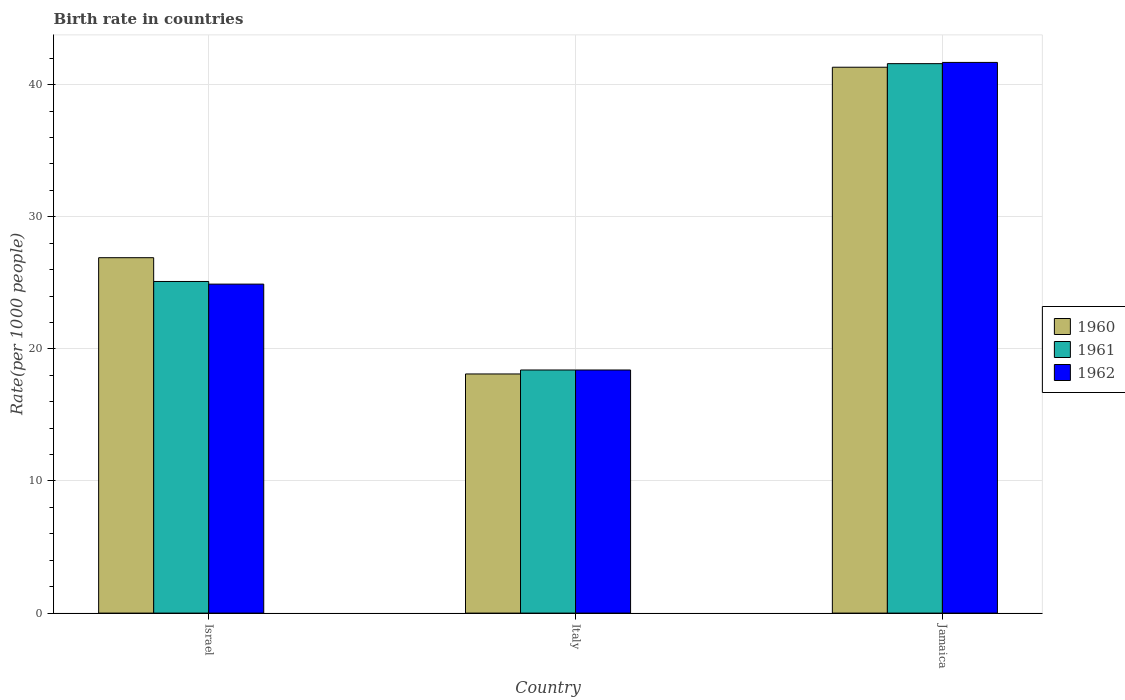How many different coloured bars are there?
Offer a very short reply. 3. How many groups of bars are there?
Ensure brevity in your answer.  3. Are the number of bars per tick equal to the number of legend labels?
Ensure brevity in your answer.  Yes. Are the number of bars on each tick of the X-axis equal?
Make the answer very short. Yes. How many bars are there on the 1st tick from the right?
Provide a short and direct response. 3. What is the label of the 3rd group of bars from the left?
Ensure brevity in your answer.  Jamaica. Across all countries, what is the maximum birth rate in 1960?
Ensure brevity in your answer.  41.32. Across all countries, what is the minimum birth rate in 1960?
Your response must be concise. 18.1. In which country was the birth rate in 1962 maximum?
Offer a terse response. Jamaica. What is the total birth rate in 1960 in the graph?
Your response must be concise. 86.32. What is the difference between the birth rate in 1961 in Italy and that in Jamaica?
Offer a terse response. -23.19. What is the difference between the birth rate in 1961 in Israel and the birth rate in 1962 in Italy?
Provide a short and direct response. 6.7. What is the average birth rate in 1962 per country?
Make the answer very short. 28.33. What is the difference between the birth rate of/in 1961 and birth rate of/in 1960 in Jamaica?
Keep it short and to the point. 0.27. What is the ratio of the birth rate in 1962 in Israel to that in Jamaica?
Make the answer very short. 0.6. What is the difference between the highest and the second highest birth rate in 1960?
Give a very brief answer. 14.42. What is the difference between the highest and the lowest birth rate in 1960?
Provide a succinct answer. 23.22. In how many countries, is the birth rate in 1961 greater than the average birth rate in 1961 taken over all countries?
Give a very brief answer. 1. Is it the case that in every country, the sum of the birth rate in 1960 and birth rate in 1962 is greater than the birth rate in 1961?
Your response must be concise. Yes. How many bars are there?
Your answer should be compact. 9. What is the difference between two consecutive major ticks on the Y-axis?
Your answer should be very brief. 10. Are the values on the major ticks of Y-axis written in scientific E-notation?
Keep it short and to the point. No. Does the graph contain any zero values?
Keep it short and to the point. No. Does the graph contain grids?
Your answer should be compact. Yes. What is the title of the graph?
Keep it short and to the point. Birth rate in countries. Does "2003" appear as one of the legend labels in the graph?
Offer a very short reply. No. What is the label or title of the X-axis?
Offer a terse response. Country. What is the label or title of the Y-axis?
Make the answer very short. Rate(per 1000 people). What is the Rate(per 1000 people) in 1960 in Israel?
Your response must be concise. 26.9. What is the Rate(per 1000 people) in 1961 in Israel?
Your response must be concise. 25.1. What is the Rate(per 1000 people) in 1962 in Israel?
Your response must be concise. 24.9. What is the Rate(per 1000 people) in 1960 in Italy?
Provide a short and direct response. 18.1. What is the Rate(per 1000 people) in 1961 in Italy?
Your response must be concise. 18.4. What is the Rate(per 1000 people) in 1962 in Italy?
Make the answer very short. 18.4. What is the Rate(per 1000 people) in 1960 in Jamaica?
Provide a short and direct response. 41.32. What is the Rate(per 1000 people) of 1961 in Jamaica?
Provide a short and direct response. 41.59. What is the Rate(per 1000 people) in 1962 in Jamaica?
Provide a short and direct response. 41.68. Across all countries, what is the maximum Rate(per 1000 people) of 1960?
Your answer should be compact. 41.32. Across all countries, what is the maximum Rate(per 1000 people) of 1961?
Your answer should be compact. 41.59. Across all countries, what is the maximum Rate(per 1000 people) of 1962?
Ensure brevity in your answer.  41.68. What is the total Rate(per 1000 people) in 1960 in the graph?
Provide a short and direct response. 86.32. What is the total Rate(per 1000 people) of 1961 in the graph?
Provide a succinct answer. 85.09. What is the total Rate(per 1000 people) of 1962 in the graph?
Offer a very short reply. 84.98. What is the difference between the Rate(per 1000 people) in 1960 in Israel and that in Italy?
Make the answer very short. 8.8. What is the difference between the Rate(per 1000 people) of 1961 in Israel and that in Italy?
Your answer should be very brief. 6.7. What is the difference between the Rate(per 1000 people) of 1962 in Israel and that in Italy?
Your response must be concise. 6.5. What is the difference between the Rate(per 1000 people) in 1960 in Israel and that in Jamaica?
Keep it short and to the point. -14.42. What is the difference between the Rate(per 1000 people) in 1961 in Israel and that in Jamaica?
Provide a succinct answer. -16.49. What is the difference between the Rate(per 1000 people) of 1962 in Israel and that in Jamaica?
Your response must be concise. -16.78. What is the difference between the Rate(per 1000 people) of 1960 in Italy and that in Jamaica?
Offer a very short reply. -23.22. What is the difference between the Rate(per 1000 people) in 1961 in Italy and that in Jamaica?
Ensure brevity in your answer.  -23.19. What is the difference between the Rate(per 1000 people) of 1962 in Italy and that in Jamaica?
Provide a short and direct response. -23.28. What is the difference between the Rate(per 1000 people) of 1960 in Israel and the Rate(per 1000 people) of 1961 in Italy?
Your answer should be compact. 8.5. What is the difference between the Rate(per 1000 people) in 1961 in Israel and the Rate(per 1000 people) in 1962 in Italy?
Give a very brief answer. 6.7. What is the difference between the Rate(per 1000 people) of 1960 in Israel and the Rate(per 1000 people) of 1961 in Jamaica?
Provide a succinct answer. -14.69. What is the difference between the Rate(per 1000 people) of 1960 in Israel and the Rate(per 1000 people) of 1962 in Jamaica?
Provide a short and direct response. -14.78. What is the difference between the Rate(per 1000 people) of 1961 in Israel and the Rate(per 1000 people) of 1962 in Jamaica?
Ensure brevity in your answer.  -16.58. What is the difference between the Rate(per 1000 people) of 1960 in Italy and the Rate(per 1000 people) of 1961 in Jamaica?
Offer a very short reply. -23.49. What is the difference between the Rate(per 1000 people) of 1960 in Italy and the Rate(per 1000 people) of 1962 in Jamaica?
Keep it short and to the point. -23.58. What is the difference between the Rate(per 1000 people) of 1961 in Italy and the Rate(per 1000 people) of 1962 in Jamaica?
Offer a very short reply. -23.28. What is the average Rate(per 1000 people) in 1960 per country?
Your answer should be compact. 28.77. What is the average Rate(per 1000 people) of 1961 per country?
Your answer should be compact. 28.36. What is the average Rate(per 1000 people) in 1962 per country?
Offer a terse response. 28.33. What is the difference between the Rate(per 1000 people) in 1960 and Rate(per 1000 people) in 1962 in Israel?
Provide a succinct answer. 2. What is the difference between the Rate(per 1000 people) in 1961 and Rate(per 1000 people) in 1962 in Israel?
Your response must be concise. 0.2. What is the difference between the Rate(per 1000 people) in 1960 and Rate(per 1000 people) in 1961 in Italy?
Offer a terse response. -0.3. What is the difference between the Rate(per 1000 people) of 1960 and Rate(per 1000 people) of 1962 in Italy?
Offer a terse response. -0.3. What is the difference between the Rate(per 1000 people) of 1961 and Rate(per 1000 people) of 1962 in Italy?
Offer a very short reply. 0. What is the difference between the Rate(per 1000 people) of 1960 and Rate(per 1000 people) of 1961 in Jamaica?
Your answer should be compact. -0.27. What is the difference between the Rate(per 1000 people) in 1960 and Rate(per 1000 people) in 1962 in Jamaica?
Give a very brief answer. -0.36. What is the difference between the Rate(per 1000 people) in 1961 and Rate(per 1000 people) in 1962 in Jamaica?
Provide a short and direct response. -0.09. What is the ratio of the Rate(per 1000 people) of 1960 in Israel to that in Italy?
Make the answer very short. 1.49. What is the ratio of the Rate(per 1000 people) in 1961 in Israel to that in Italy?
Your response must be concise. 1.36. What is the ratio of the Rate(per 1000 people) of 1962 in Israel to that in Italy?
Offer a terse response. 1.35. What is the ratio of the Rate(per 1000 people) in 1960 in Israel to that in Jamaica?
Make the answer very short. 0.65. What is the ratio of the Rate(per 1000 people) of 1961 in Israel to that in Jamaica?
Keep it short and to the point. 0.6. What is the ratio of the Rate(per 1000 people) in 1962 in Israel to that in Jamaica?
Ensure brevity in your answer.  0.6. What is the ratio of the Rate(per 1000 people) of 1960 in Italy to that in Jamaica?
Give a very brief answer. 0.44. What is the ratio of the Rate(per 1000 people) in 1961 in Italy to that in Jamaica?
Your answer should be compact. 0.44. What is the ratio of the Rate(per 1000 people) in 1962 in Italy to that in Jamaica?
Provide a succinct answer. 0.44. What is the difference between the highest and the second highest Rate(per 1000 people) of 1960?
Ensure brevity in your answer.  14.42. What is the difference between the highest and the second highest Rate(per 1000 people) of 1961?
Offer a very short reply. 16.49. What is the difference between the highest and the second highest Rate(per 1000 people) in 1962?
Provide a succinct answer. 16.78. What is the difference between the highest and the lowest Rate(per 1000 people) in 1960?
Your answer should be compact. 23.22. What is the difference between the highest and the lowest Rate(per 1000 people) in 1961?
Keep it short and to the point. 23.19. What is the difference between the highest and the lowest Rate(per 1000 people) in 1962?
Your answer should be compact. 23.28. 